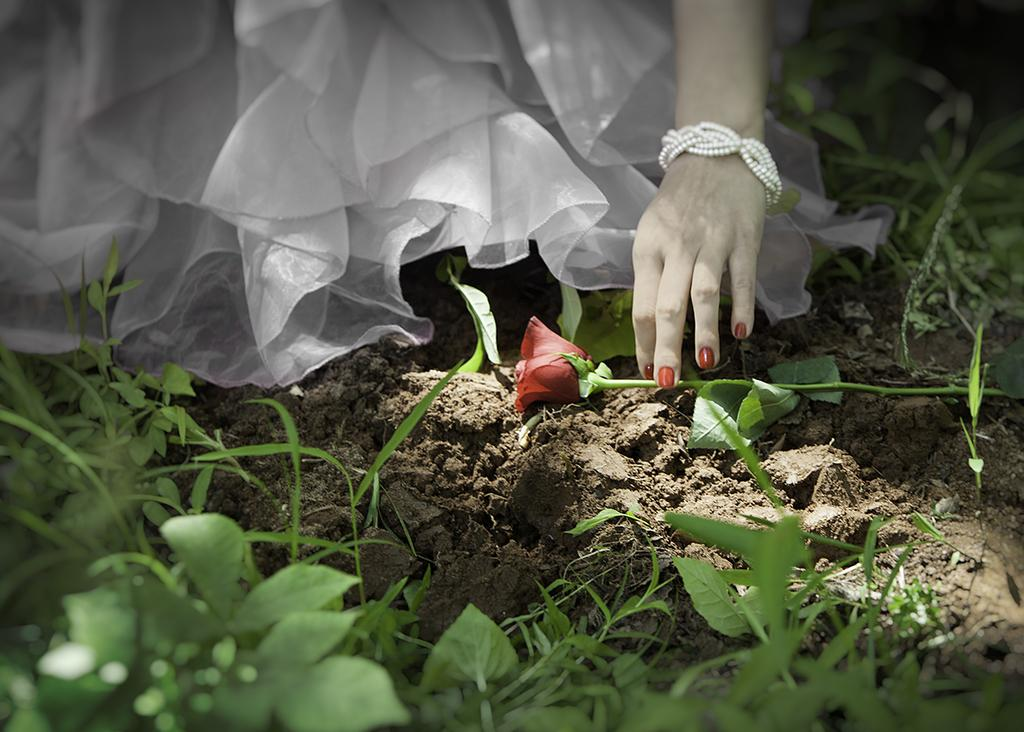What type of plant material is present in the image? There are leaves in the image. What type of flower can be seen in the image? There is a rose flower in the image. What type of soil is present in the image? There is mud in the image. Whose hand is visible in the image? A person's hand is visible in the image. What type of accessory is present in the image? There is a bracelet in the image. What type of fabric is present in the image? There is a white cloth in the image. What type of pan is being used to cause the leaves to change color in the image? There is no pan or any indication of leaves changing color in the image. Is there a bath visible in the image? No, there is no bath present in the image. 